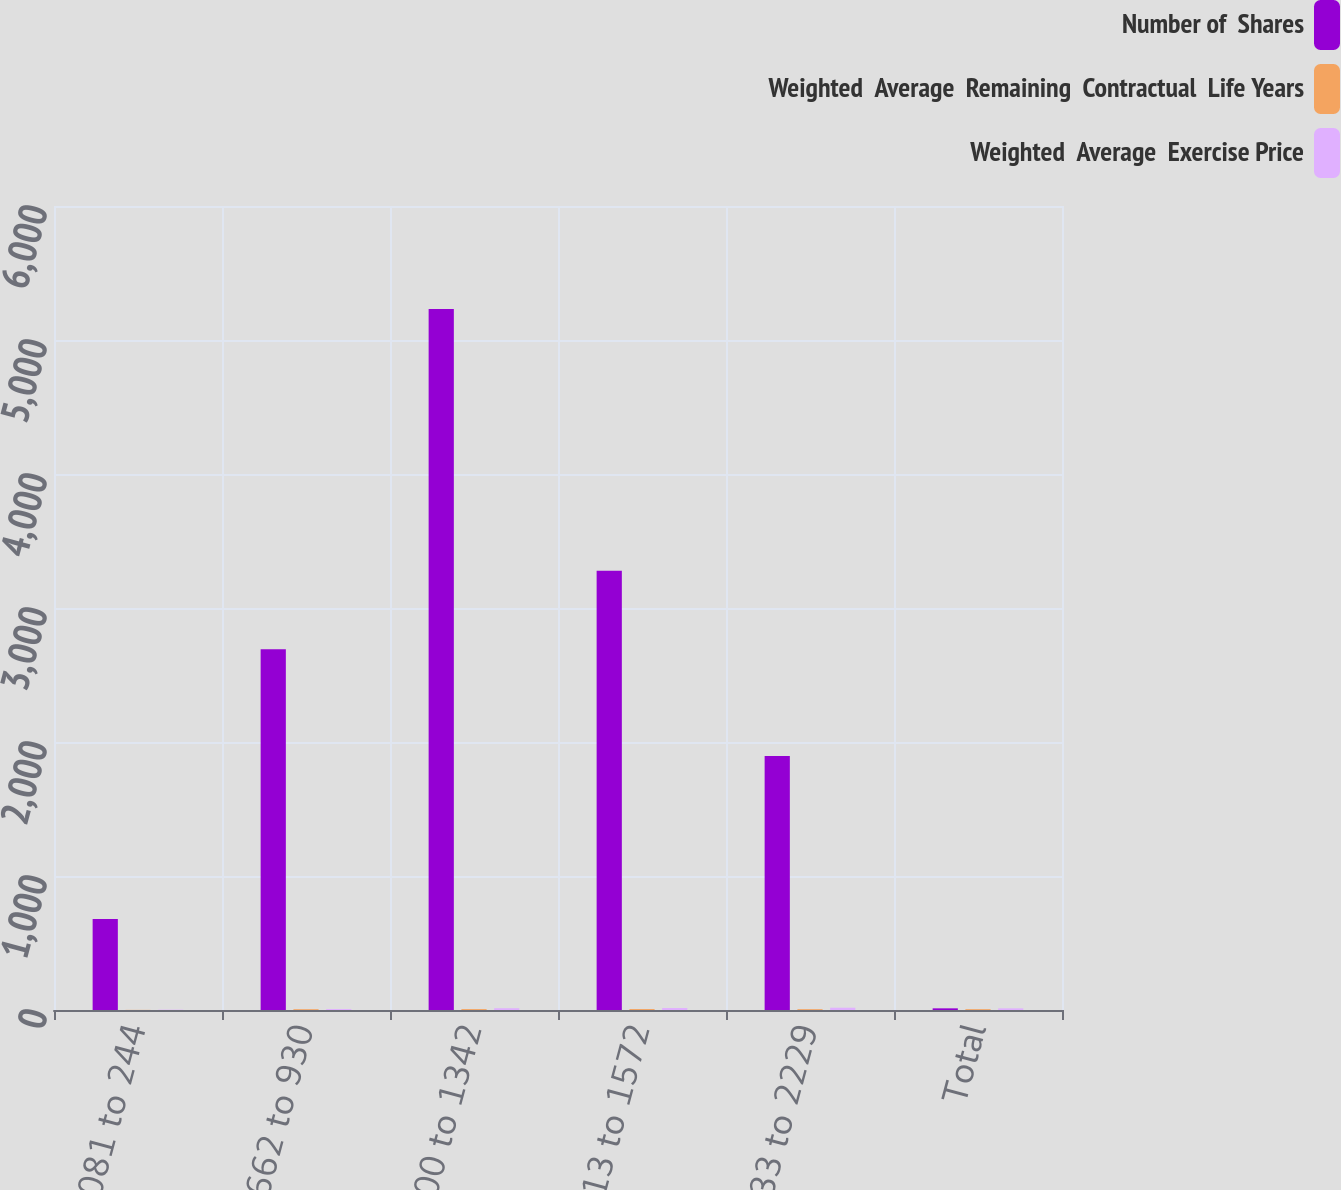Convert chart. <chart><loc_0><loc_0><loc_500><loc_500><stacked_bar_chart><ecel><fcel>081 to 244<fcel>662 to 930<fcel>1000 to 1342<fcel>1413 to 1572<fcel>1633 to 2229<fcel>Total<nl><fcel>Number of  Shares<fcel>679<fcel>2692<fcel>5231<fcel>3278<fcel>1895<fcel>12.39<nl><fcel>Weighted  Average  Remaining  Contractual  Life Years<fcel>1<fcel>6<fcel>6.8<fcel>7.1<fcel>6.2<fcel>6.3<nl><fcel>Weighted  Average  Exercise Price<fcel>2.43<fcel>7.16<fcel>13.21<fcel>14.71<fcel>17.15<fcel>12.39<nl></chart> 